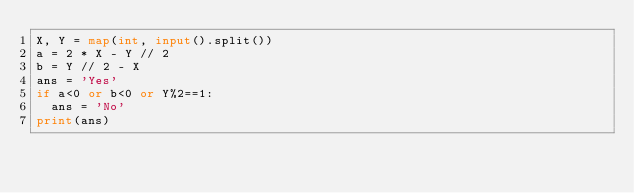Convert code to text. <code><loc_0><loc_0><loc_500><loc_500><_Python_>X, Y = map(int, input().split())
a = 2 * X - Y // 2
b = Y // 2 - X
ans = 'Yes'
if a<0 or b<0 or Y%2==1:
  ans = 'No'
print(ans)</code> 